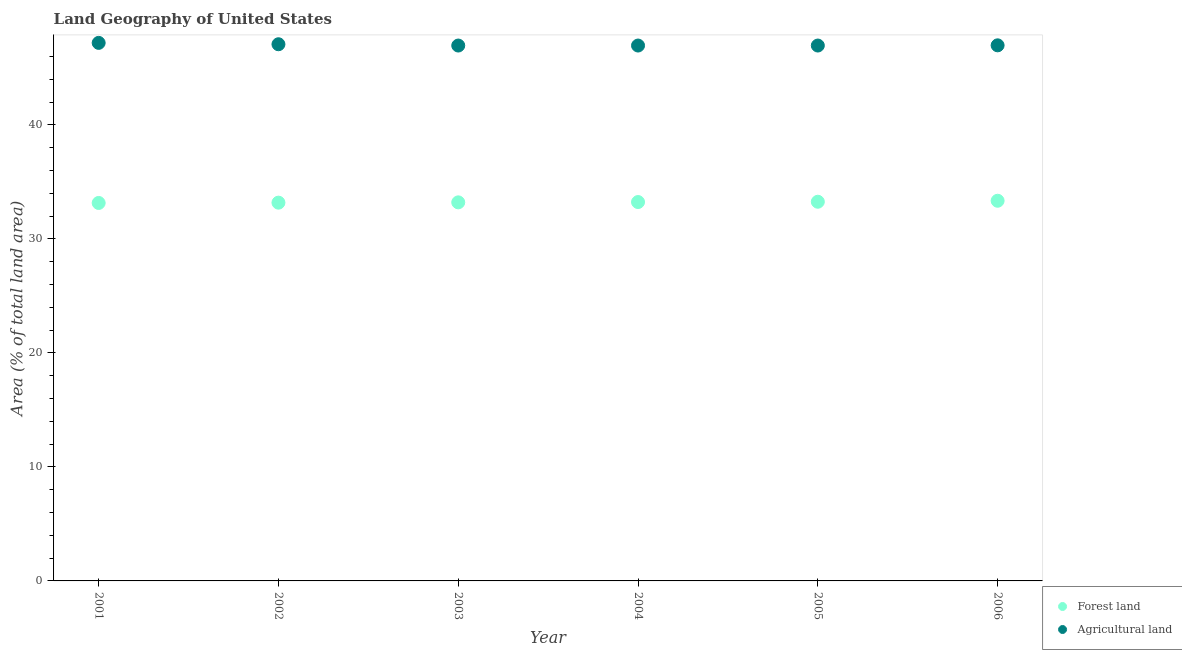How many different coloured dotlines are there?
Your response must be concise. 2. What is the percentage of land area under forests in 2004?
Keep it short and to the point. 33.24. Across all years, what is the maximum percentage of land area under forests?
Make the answer very short. 33.35. Across all years, what is the minimum percentage of land area under forests?
Your answer should be very brief. 33.16. In which year was the percentage of land area under agriculture maximum?
Give a very brief answer. 2001. In which year was the percentage of land area under forests minimum?
Your response must be concise. 2001. What is the total percentage of land area under forests in the graph?
Your answer should be compact. 199.4. What is the difference between the percentage of land area under forests in 2003 and that in 2004?
Keep it short and to the point. -0.03. What is the difference between the percentage of land area under agriculture in 2002 and the percentage of land area under forests in 2004?
Give a very brief answer. 13.84. What is the average percentage of land area under forests per year?
Offer a very short reply. 33.23. In the year 2001, what is the difference between the percentage of land area under agriculture and percentage of land area under forests?
Your response must be concise. 14.04. What is the ratio of the percentage of land area under agriculture in 2001 to that in 2003?
Provide a succinct answer. 1. Is the difference between the percentage of land area under agriculture in 2002 and 2004 greater than the difference between the percentage of land area under forests in 2002 and 2004?
Make the answer very short. Yes. What is the difference between the highest and the second highest percentage of land area under forests?
Offer a very short reply. 0.09. What is the difference between the highest and the lowest percentage of land area under agriculture?
Offer a very short reply. 0.23. Is the sum of the percentage of land area under agriculture in 2002 and 2004 greater than the maximum percentage of land area under forests across all years?
Your answer should be compact. Yes. Is the percentage of land area under agriculture strictly greater than the percentage of land area under forests over the years?
Keep it short and to the point. Yes. How many dotlines are there?
Provide a short and direct response. 2. Are the values on the major ticks of Y-axis written in scientific E-notation?
Make the answer very short. No. Does the graph contain any zero values?
Give a very brief answer. No. Does the graph contain grids?
Ensure brevity in your answer.  No. How are the legend labels stacked?
Give a very brief answer. Vertical. What is the title of the graph?
Offer a terse response. Land Geography of United States. What is the label or title of the Y-axis?
Give a very brief answer. Area (% of total land area). What is the Area (% of total land area) in Forest land in 2001?
Offer a terse response. 33.16. What is the Area (% of total land area) of Agricultural land in 2001?
Offer a terse response. 47.2. What is the Area (% of total land area) of Forest land in 2002?
Ensure brevity in your answer.  33.18. What is the Area (% of total land area) in Agricultural land in 2002?
Your answer should be very brief. 47.08. What is the Area (% of total land area) in Forest land in 2003?
Offer a very short reply. 33.21. What is the Area (% of total land area) in Agricultural land in 2003?
Keep it short and to the point. 46.97. What is the Area (% of total land area) in Forest land in 2004?
Give a very brief answer. 33.24. What is the Area (% of total land area) in Agricultural land in 2004?
Your answer should be very brief. 46.97. What is the Area (% of total land area) in Forest land in 2005?
Your answer should be compact. 33.26. What is the Area (% of total land area) of Agricultural land in 2005?
Offer a terse response. 46.97. What is the Area (% of total land area) of Forest land in 2006?
Ensure brevity in your answer.  33.35. What is the Area (% of total land area) of Agricultural land in 2006?
Keep it short and to the point. 46.98. Across all years, what is the maximum Area (% of total land area) in Forest land?
Keep it short and to the point. 33.35. Across all years, what is the maximum Area (% of total land area) of Agricultural land?
Your answer should be compact. 47.2. Across all years, what is the minimum Area (% of total land area) in Forest land?
Your answer should be compact. 33.16. Across all years, what is the minimum Area (% of total land area) of Agricultural land?
Your answer should be compact. 46.97. What is the total Area (% of total land area) in Forest land in the graph?
Make the answer very short. 199.4. What is the total Area (% of total land area) of Agricultural land in the graph?
Your answer should be compact. 282.16. What is the difference between the Area (% of total land area) of Forest land in 2001 and that in 2002?
Your answer should be compact. -0.03. What is the difference between the Area (% of total land area) of Agricultural land in 2001 and that in 2002?
Provide a succinct answer. 0.12. What is the difference between the Area (% of total land area) in Forest land in 2001 and that in 2003?
Provide a short and direct response. -0.05. What is the difference between the Area (% of total land area) in Agricultural land in 2001 and that in 2003?
Provide a short and direct response. 0.23. What is the difference between the Area (% of total land area) of Forest land in 2001 and that in 2004?
Provide a succinct answer. -0.08. What is the difference between the Area (% of total land area) of Agricultural land in 2001 and that in 2004?
Ensure brevity in your answer.  0.23. What is the difference between the Area (% of total land area) in Forest land in 2001 and that in 2005?
Provide a succinct answer. -0.11. What is the difference between the Area (% of total land area) of Agricultural land in 2001 and that in 2005?
Offer a very short reply. 0.23. What is the difference between the Area (% of total land area) in Forest land in 2001 and that in 2006?
Your response must be concise. -0.19. What is the difference between the Area (% of total land area) of Agricultural land in 2001 and that in 2006?
Your answer should be very brief. 0.21. What is the difference between the Area (% of total land area) in Forest land in 2002 and that in 2003?
Your answer should be very brief. -0.03. What is the difference between the Area (% of total land area) in Agricultural land in 2002 and that in 2003?
Keep it short and to the point. 0.11. What is the difference between the Area (% of total land area) in Forest land in 2002 and that in 2004?
Keep it short and to the point. -0.05. What is the difference between the Area (% of total land area) in Agricultural land in 2002 and that in 2004?
Your response must be concise. 0.11. What is the difference between the Area (% of total land area) in Forest land in 2002 and that in 2005?
Offer a terse response. -0.08. What is the difference between the Area (% of total land area) in Agricultural land in 2002 and that in 2005?
Offer a very short reply. 0.11. What is the difference between the Area (% of total land area) in Forest land in 2002 and that in 2006?
Provide a short and direct response. -0.17. What is the difference between the Area (% of total land area) of Agricultural land in 2002 and that in 2006?
Provide a short and direct response. 0.09. What is the difference between the Area (% of total land area) in Forest land in 2003 and that in 2004?
Your answer should be compact. -0.03. What is the difference between the Area (% of total land area) of Forest land in 2003 and that in 2005?
Offer a very short reply. -0.05. What is the difference between the Area (% of total land area) of Agricultural land in 2003 and that in 2005?
Provide a short and direct response. 0. What is the difference between the Area (% of total land area) of Forest land in 2003 and that in 2006?
Provide a succinct answer. -0.14. What is the difference between the Area (% of total land area) in Agricultural land in 2003 and that in 2006?
Your response must be concise. -0.02. What is the difference between the Area (% of total land area) of Forest land in 2004 and that in 2005?
Offer a very short reply. -0.03. What is the difference between the Area (% of total land area) of Agricultural land in 2004 and that in 2005?
Ensure brevity in your answer.  0. What is the difference between the Area (% of total land area) of Forest land in 2004 and that in 2006?
Ensure brevity in your answer.  -0.11. What is the difference between the Area (% of total land area) of Agricultural land in 2004 and that in 2006?
Give a very brief answer. -0.02. What is the difference between the Area (% of total land area) of Forest land in 2005 and that in 2006?
Give a very brief answer. -0.09. What is the difference between the Area (% of total land area) in Agricultural land in 2005 and that in 2006?
Your answer should be very brief. -0.02. What is the difference between the Area (% of total land area) in Forest land in 2001 and the Area (% of total land area) in Agricultural land in 2002?
Your response must be concise. -13.92. What is the difference between the Area (% of total land area) in Forest land in 2001 and the Area (% of total land area) in Agricultural land in 2003?
Ensure brevity in your answer.  -13.81. What is the difference between the Area (% of total land area) in Forest land in 2001 and the Area (% of total land area) in Agricultural land in 2004?
Provide a succinct answer. -13.81. What is the difference between the Area (% of total land area) in Forest land in 2001 and the Area (% of total land area) in Agricultural land in 2005?
Your response must be concise. -13.81. What is the difference between the Area (% of total land area) in Forest land in 2001 and the Area (% of total land area) in Agricultural land in 2006?
Your answer should be compact. -13.83. What is the difference between the Area (% of total land area) of Forest land in 2002 and the Area (% of total land area) of Agricultural land in 2003?
Offer a very short reply. -13.78. What is the difference between the Area (% of total land area) of Forest land in 2002 and the Area (% of total land area) of Agricultural land in 2004?
Your answer should be very brief. -13.78. What is the difference between the Area (% of total land area) of Forest land in 2002 and the Area (% of total land area) of Agricultural land in 2005?
Make the answer very short. -13.78. What is the difference between the Area (% of total land area) of Forest land in 2002 and the Area (% of total land area) of Agricultural land in 2006?
Give a very brief answer. -13.8. What is the difference between the Area (% of total land area) of Forest land in 2003 and the Area (% of total land area) of Agricultural land in 2004?
Offer a very short reply. -13.76. What is the difference between the Area (% of total land area) of Forest land in 2003 and the Area (% of total land area) of Agricultural land in 2005?
Your answer should be compact. -13.76. What is the difference between the Area (% of total land area) in Forest land in 2003 and the Area (% of total land area) in Agricultural land in 2006?
Keep it short and to the point. -13.77. What is the difference between the Area (% of total land area) of Forest land in 2004 and the Area (% of total land area) of Agricultural land in 2005?
Offer a terse response. -13.73. What is the difference between the Area (% of total land area) in Forest land in 2004 and the Area (% of total land area) in Agricultural land in 2006?
Your answer should be compact. -13.75. What is the difference between the Area (% of total land area) of Forest land in 2005 and the Area (% of total land area) of Agricultural land in 2006?
Your answer should be compact. -13.72. What is the average Area (% of total land area) of Forest land per year?
Offer a very short reply. 33.23. What is the average Area (% of total land area) of Agricultural land per year?
Make the answer very short. 47.03. In the year 2001, what is the difference between the Area (% of total land area) of Forest land and Area (% of total land area) of Agricultural land?
Make the answer very short. -14.04. In the year 2002, what is the difference between the Area (% of total land area) of Forest land and Area (% of total land area) of Agricultural land?
Your answer should be very brief. -13.9. In the year 2003, what is the difference between the Area (% of total land area) of Forest land and Area (% of total land area) of Agricultural land?
Give a very brief answer. -13.76. In the year 2004, what is the difference between the Area (% of total land area) of Forest land and Area (% of total land area) of Agricultural land?
Ensure brevity in your answer.  -13.73. In the year 2005, what is the difference between the Area (% of total land area) in Forest land and Area (% of total land area) in Agricultural land?
Keep it short and to the point. -13.7. In the year 2006, what is the difference between the Area (% of total land area) of Forest land and Area (% of total land area) of Agricultural land?
Ensure brevity in your answer.  -13.63. What is the ratio of the Area (% of total land area) in Forest land in 2001 to that in 2003?
Ensure brevity in your answer.  1. What is the ratio of the Area (% of total land area) of Agricultural land in 2001 to that in 2003?
Make the answer very short. 1. What is the ratio of the Area (% of total land area) in Forest land in 2001 to that in 2004?
Keep it short and to the point. 1. What is the ratio of the Area (% of total land area) in Agricultural land in 2001 to that in 2004?
Keep it short and to the point. 1. What is the ratio of the Area (% of total land area) in Agricultural land in 2001 to that in 2005?
Provide a succinct answer. 1. What is the ratio of the Area (% of total land area) in Forest land in 2001 to that in 2006?
Ensure brevity in your answer.  0.99. What is the ratio of the Area (% of total land area) of Agricultural land in 2001 to that in 2006?
Your answer should be compact. 1. What is the ratio of the Area (% of total land area) of Forest land in 2002 to that in 2003?
Your response must be concise. 1. What is the ratio of the Area (% of total land area) of Agricultural land in 2002 to that in 2004?
Provide a succinct answer. 1. What is the ratio of the Area (% of total land area) in Forest land in 2002 to that in 2006?
Your answer should be very brief. 0.99. What is the ratio of the Area (% of total land area) of Agricultural land in 2002 to that in 2006?
Keep it short and to the point. 1. What is the ratio of the Area (% of total land area) in Forest land in 2003 to that in 2004?
Offer a terse response. 1. What is the ratio of the Area (% of total land area) of Agricultural land in 2003 to that in 2004?
Your response must be concise. 1. What is the ratio of the Area (% of total land area) in Agricultural land in 2004 to that in 2005?
Your response must be concise. 1. What is the ratio of the Area (% of total land area) of Forest land in 2004 to that in 2006?
Give a very brief answer. 1. What is the ratio of the Area (% of total land area) in Forest land in 2005 to that in 2006?
Give a very brief answer. 1. What is the difference between the highest and the second highest Area (% of total land area) of Forest land?
Your answer should be compact. 0.09. What is the difference between the highest and the second highest Area (% of total land area) of Agricultural land?
Make the answer very short. 0.12. What is the difference between the highest and the lowest Area (% of total land area) of Forest land?
Make the answer very short. 0.19. What is the difference between the highest and the lowest Area (% of total land area) of Agricultural land?
Offer a terse response. 0.23. 